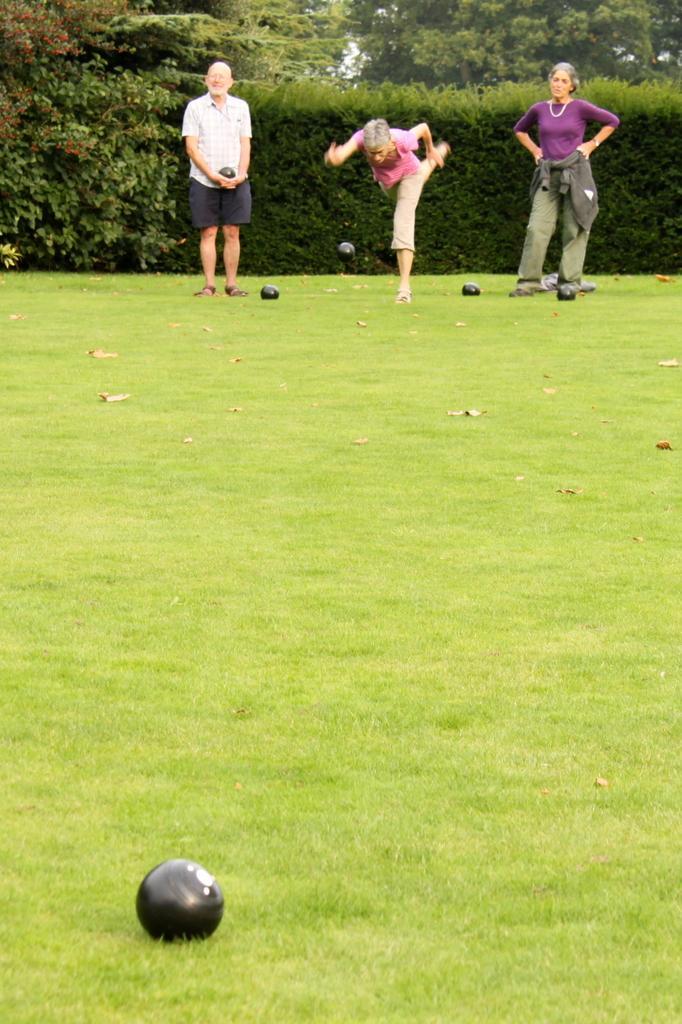In one or two sentences, can you explain what this image depicts? In this picture we can see people and balls on the ground and one ball is in the air and in the background we can see trees and plants. 